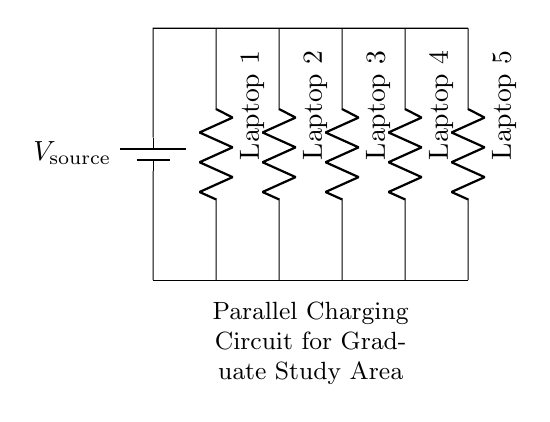What is the type of circuit shown? The circuit is a parallel circuit since all the laptops are connected along the same voltage source, providing the same potential difference across each device.
Answer: Parallel How many laptops are being charged? There are five laptops connected in this circuit, as indicated by the five resistors labeled Laptop 1 through Laptop 5.
Answer: Five What is the role of the battery in this circuit? The battery serves as the voltage source, providing the necessary electrical energy to power all the laptops in the parallel configuration.
Answer: Voltage source What will happen if one laptop is disconnected? If one laptop is disconnected, the other laptops will continue to function normally, as the voltage across each remains the same, demonstrating the nature of parallel connections.
Answer: Continue functioning What is the current through each laptop if the total current is fifteen amperes? In a parallel circuit, the total current is the sum of the individual currents. If there are five laptops, the current through each would be three amperes if the current is evenly distributed.
Answer: Three What is the voltage across each laptop? In a parallel circuit, the voltage across all components is the same and equals the voltage of the source. Thus, if the source voltage is 5 volts, then each laptop experiences 5 volts.
Answer: Five volts 